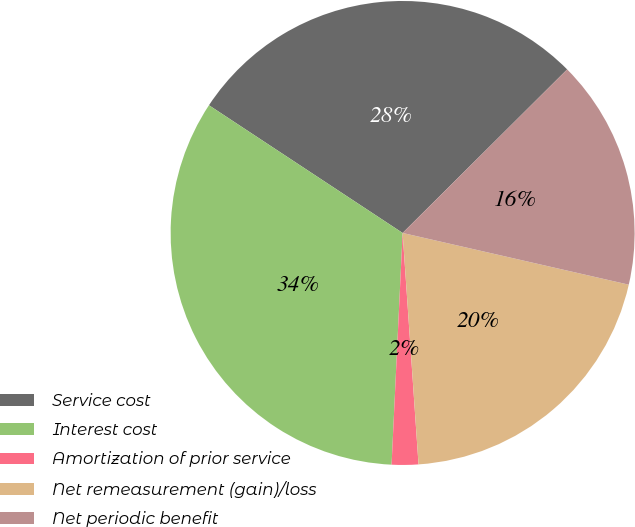Convert chart. <chart><loc_0><loc_0><loc_500><loc_500><pie_chart><fcel>Service cost<fcel>Interest cost<fcel>Amortization of prior service<fcel>Net remeasurement (gain)/loss<fcel>Net periodic benefit<nl><fcel>28.27%<fcel>33.52%<fcel>1.85%<fcel>20.33%<fcel>16.03%<nl></chart> 